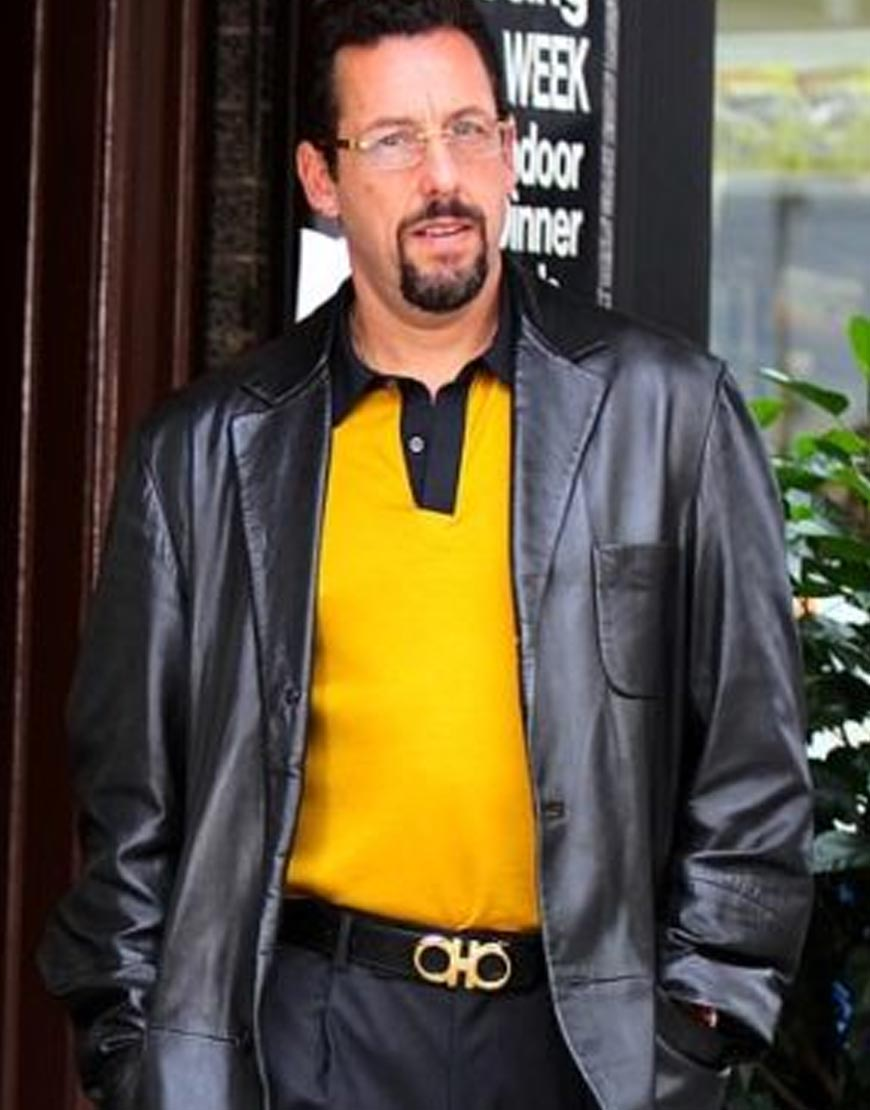How might his day have been leading up to this moment based on visible clues? Judging from his attire and the composed expression on his face, it can be inferred that he has had a relatively important and perhaps formal day. The smart casual outfit of a stylish leather jacket over a yellow shirt, combined with neatly maintained hair and a belt, suggests he might have attended a business meeting, a social gathering, or an important event earlier in the day. His calm demeanor indicates he could be used to such events, handling busy schedules and maintaining a poised presence. 